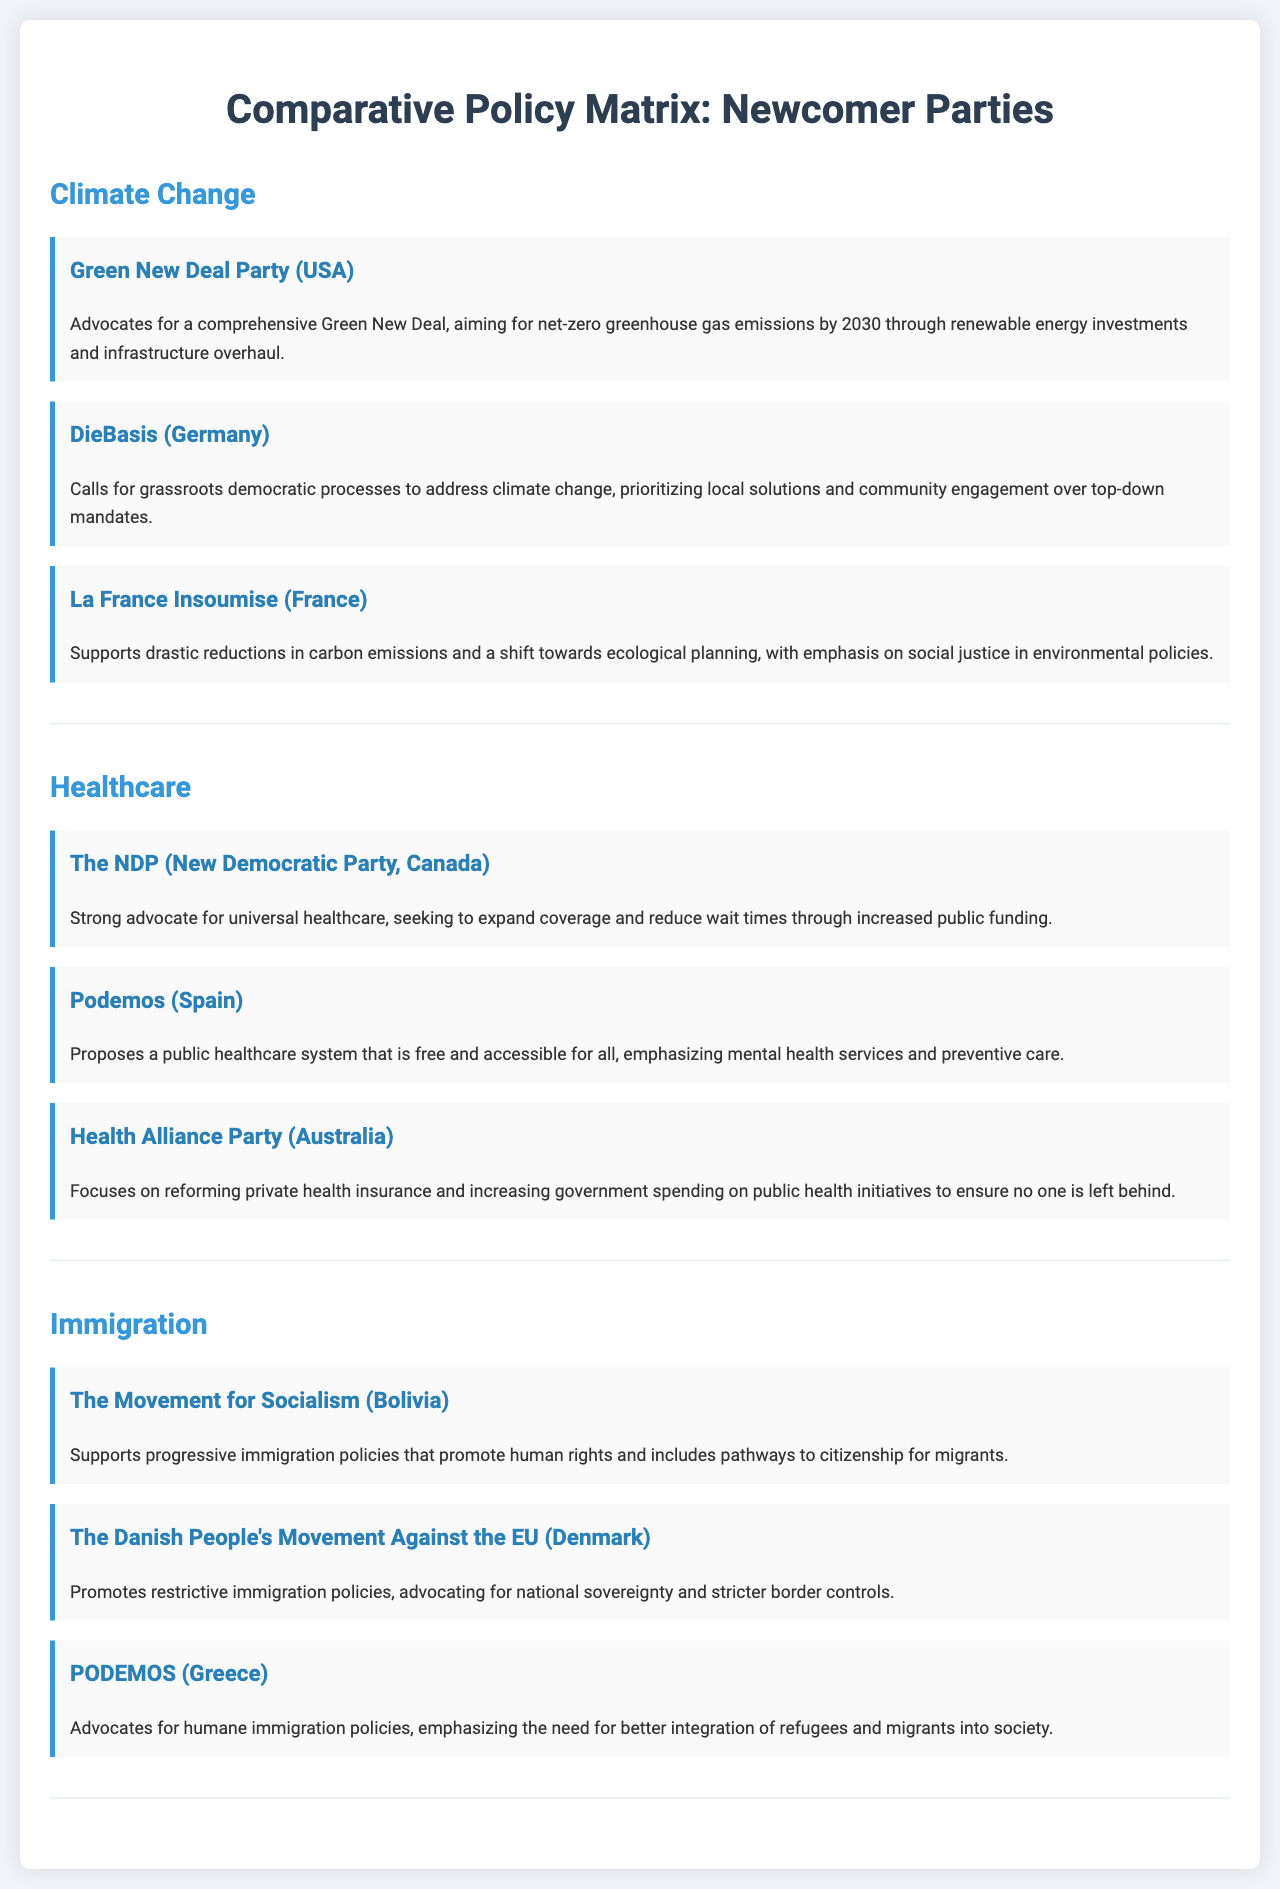What party advocates for a comprehensive Green New Deal? The document states that the Green New Deal Party (USA) advocates for a comprehensive Green New Deal.
Answer: Green New Deal Party (USA) What year does the Green New Deal aim for net-zero emissions? The document notes that the Green New Deal aims for net-zero greenhouse gas emissions by 2030.
Answer: 2030 Which party focuses on reforming private health insurance in Australia? According to the document, the Health Alliance Party (Australia) focuses on reforming private health insurance.
Answer: Health Alliance Party (Australia) How many parties are mentioned under the immigration issue? The document lists three parties under the immigration issue.
Answer: 3 What is the emphasis of La France Insoumise's environmental policies? The document indicates that La France Insoumise emphasizes social justice in environmental policies.
Answer: Social justice What is Podemos' stance on healthcare accessibility? The document describes Podemos (Spain) as proposing a public healthcare system that is free and accessible for all.
Answer: Free and accessible Which party calls for grassroots democratic processes to address climate change? The document mentions DieBasis (Germany) as calling for grassroots democratic processes.
Answer: DieBasis (Germany) What does The Movement for Socialism support regarding immigration? The document states that The Movement for Socialism supports progressive immigration policies promoting human rights.
Answer: Progressive immigration policies 